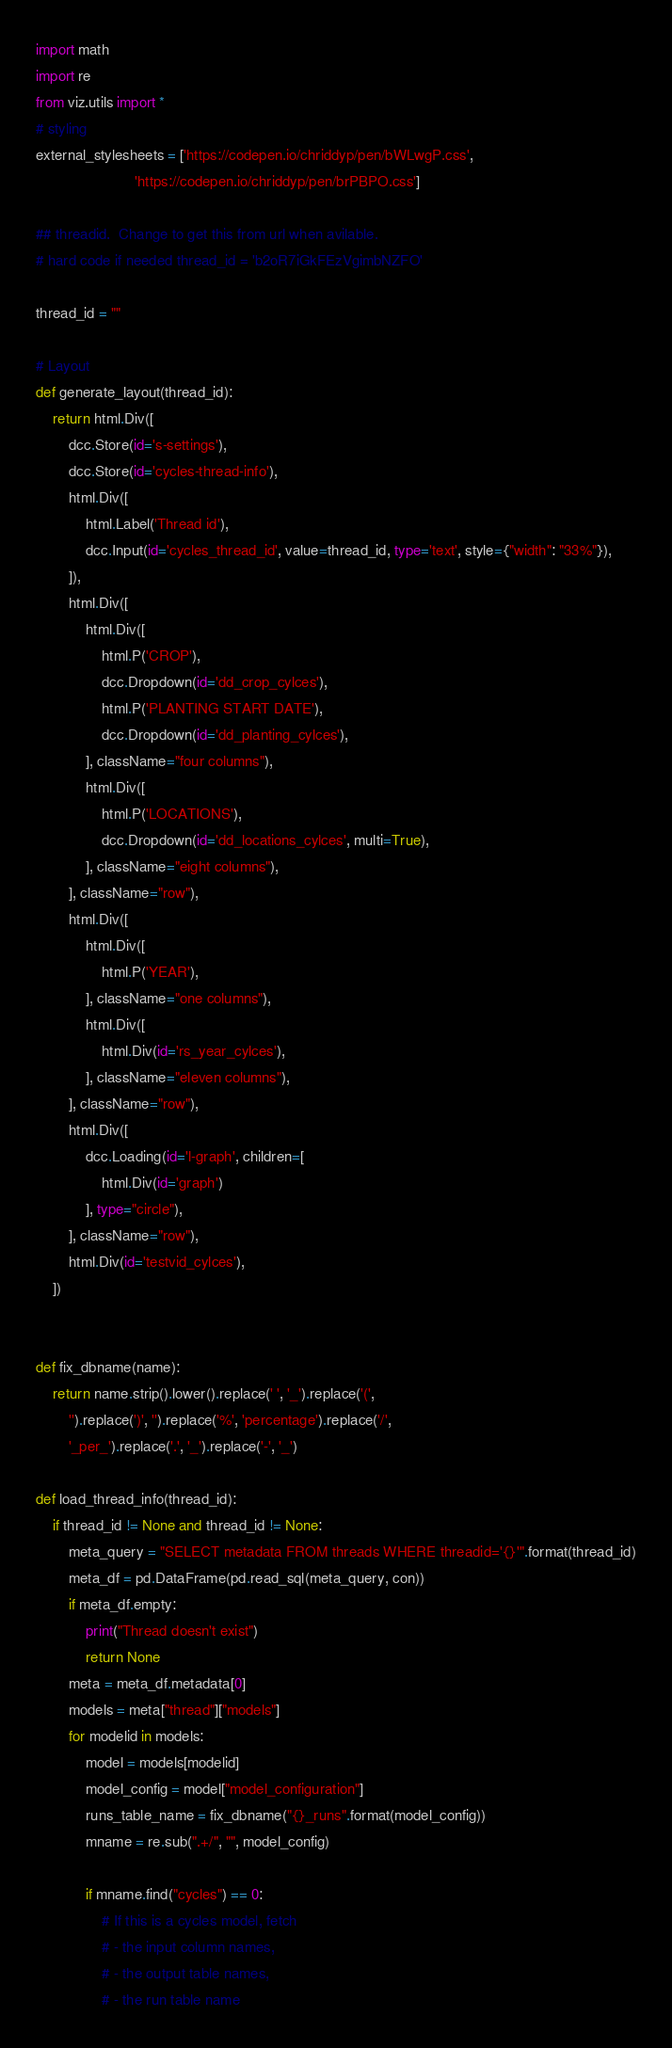Convert code to text. <code><loc_0><loc_0><loc_500><loc_500><_Python_>import math
import re
from viz.utils import * 
# styling
external_stylesheets = ['https://codepen.io/chriddyp/pen/bWLwgP.css',
                        'https://codepen.io/chriddyp/pen/brPBPO.css']

## threadid.  Change to get this from url when avilable.
# hard code if needed thread_id = 'b2oR7iGkFEzVgimbNZFO'

thread_id = ""

# Layout
def generate_layout(thread_id):
    return html.Div([
        dcc.Store(id='s-settings'),
        dcc.Store(id='cycles-thread-info'),
        html.Div([
            html.Label('Thread id'),
            dcc.Input(id='cycles_thread_id', value=thread_id, type='text', style={"width": "33%"}),
        ]),
        html.Div([
            html.Div([
                html.P('CROP'),
                dcc.Dropdown(id='dd_crop_cylces'),
                html.P('PLANTING START DATE'),
                dcc.Dropdown(id='dd_planting_cylces'),
            ], className="four columns"),
            html.Div([
                html.P('LOCATIONS'),
                dcc.Dropdown(id='dd_locations_cylces', multi=True),
            ], className="eight columns"),
        ], className="row"),
        html.Div([
            html.Div([
                html.P('YEAR'),
            ], className="one columns"),
            html.Div([
                html.Div(id='rs_year_cylces'),
            ], className="eleven columns"),
        ], className="row"),
        html.Div([
            dcc.Loading(id='l-graph', children=[
                html.Div(id='graph')
            ], type="circle"),
        ], className="row"),
        html.Div(id='testvid_cylces'),
    ])


def fix_dbname(name):
    return name.strip().lower().replace(' ', '_').replace('(',
        '').replace(')', '').replace('%', 'percentage').replace('/', 
        '_per_').replace('.', '_').replace('-', '_')

def load_thread_info(thread_id):
    if thread_id != None and thread_id != None:
        meta_query = "SELECT metadata FROM threads WHERE threadid='{}'".format(thread_id)
        meta_df = pd.DataFrame(pd.read_sql(meta_query, con))
        if meta_df.empty:
            print("Thread doesn't exist")
            return None
        meta = meta_df.metadata[0]
        models = meta["thread"]["models"]
        for modelid in models:
            model = models[modelid]
            model_config = model["model_configuration"]
            runs_table_name = fix_dbname("{}_runs".format(model_config))
            mname = re.sub(".+/", "", model_config)

            if mname.find("cycles") == 0: 
                # If this is a cycles model, fetch 
                # - the input column names, 
                # - the output table names, 
                # - the run table name
</code> 